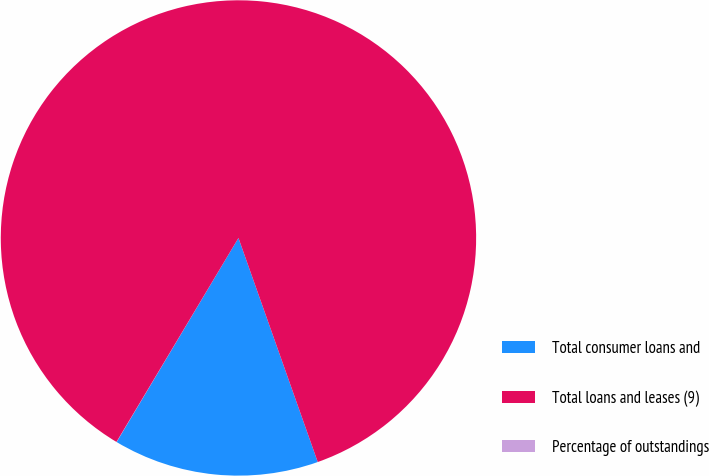<chart> <loc_0><loc_0><loc_500><loc_500><pie_chart><fcel>Total consumer loans and<fcel>Total loans and leases (9)<fcel>Percentage of outstandings<nl><fcel>13.98%<fcel>86.01%<fcel>0.01%<nl></chart> 